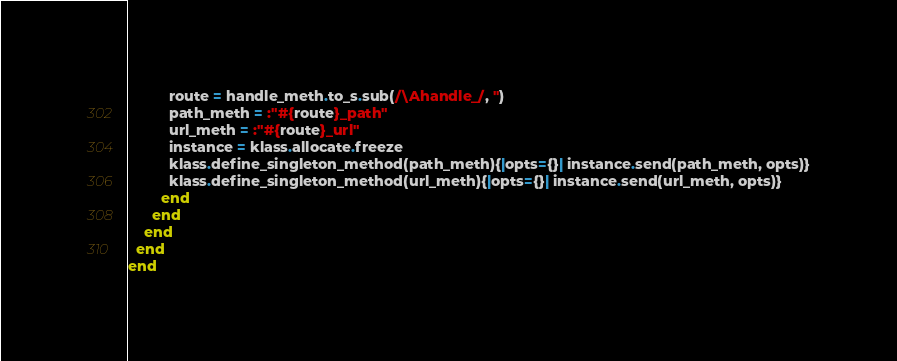<code> <loc_0><loc_0><loc_500><loc_500><_Ruby_>          route = handle_meth.to_s.sub(/\Ahandle_/, '')
          path_meth = :"#{route}_path"
          url_meth = :"#{route}_url"
          instance = klass.allocate.freeze
          klass.define_singleton_method(path_meth){|opts={}| instance.send(path_meth, opts)}
          klass.define_singleton_method(url_meth){|opts={}| instance.send(url_meth, opts)}
        end
      end
    end
  end
end
</code> 